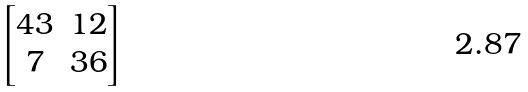Convert formula to latex. <formula><loc_0><loc_0><loc_500><loc_500>\begin{bmatrix} 4 3 & 1 2 \\ 7 & 3 6 \end{bmatrix}</formula> 